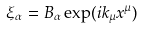Convert formula to latex. <formula><loc_0><loc_0><loc_500><loc_500>\xi _ { \alpha } = B _ { \alpha } \exp ( i k _ { \mu } x ^ { \mu } )</formula> 